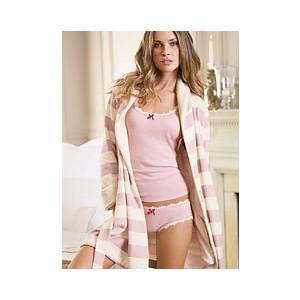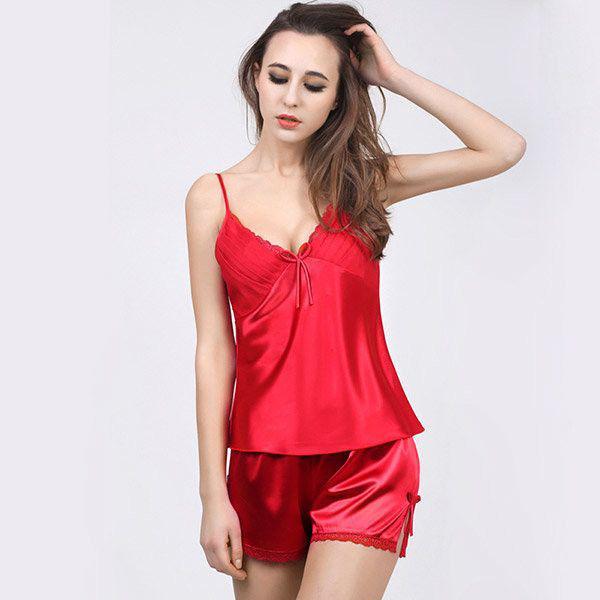The first image is the image on the left, the second image is the image on the right. Given the left and right images, does the statement "A model wears a long-sleeved robe-type cover-up over intimate apparel in one image." hold true? Answer yes or no. Yes. The first image is the image on the left, the second image is the image on the right. Analyze the images presented: Is the assertion "One solid color pajama set has a top with straps and lacy bra area, as well as a very short matching bottom." valid? Answer yes or no. Yes. 